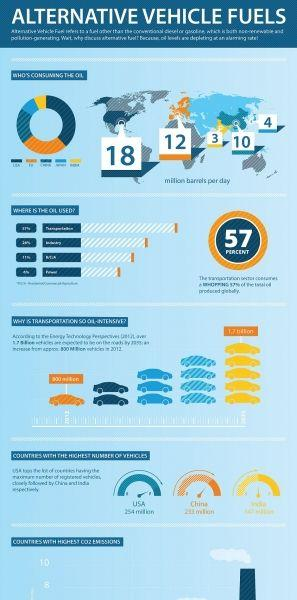Point out several critical features in this image. There are five yellow cars shown in the image. The infographic displays 15 cars. 